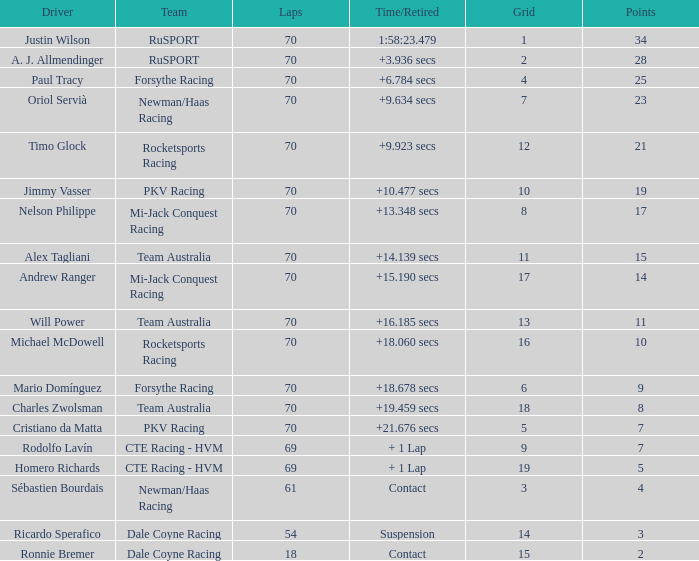Who scored with a grid of 10 and the highest amount of laps? 70.0. 